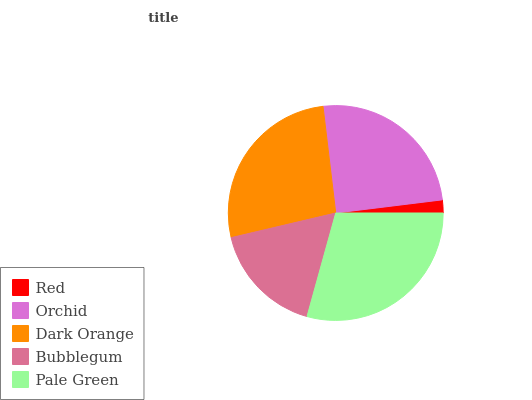Is Red the minimum?
Answer yes or no. Yes. Is Pale Green the maximum?
Answer yes or no. Yes. Is Orchid the minimum?
Answer yes or no. No. Is Orchid the maximum?
Answer yes or no. No. Is Orchid greater than Red?
Answer yes or no. Yes. Is Red less than Orchid?
Answer yes or no. Yes. Is Red greater than Orchid?
Answer yes or no. No. Is Orchid less than Red?
Answer yes or no. No. Is Orchid the high median?
Answer yes or no. Yes. Is Orchid the low median?
Answer yes or no. Yes. Is Red the high median?
Answer yes or no. No. Is Bubblegum the low median?
Answer yes or no. No. 